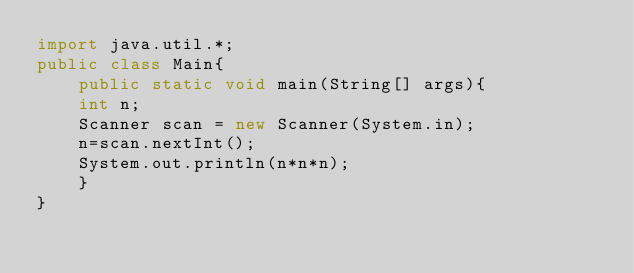Convert code to text. <code><loc_0><loc_0><loc_500><loc_500><_Java_>import java.util.*;
public class Main{
    public static void main(String[] args){
	int n;
	Scanner scan = new Scanner(System.in);
	n=scan.nextInt();
	System.out.println(n*n*n);
    }
}</code> 